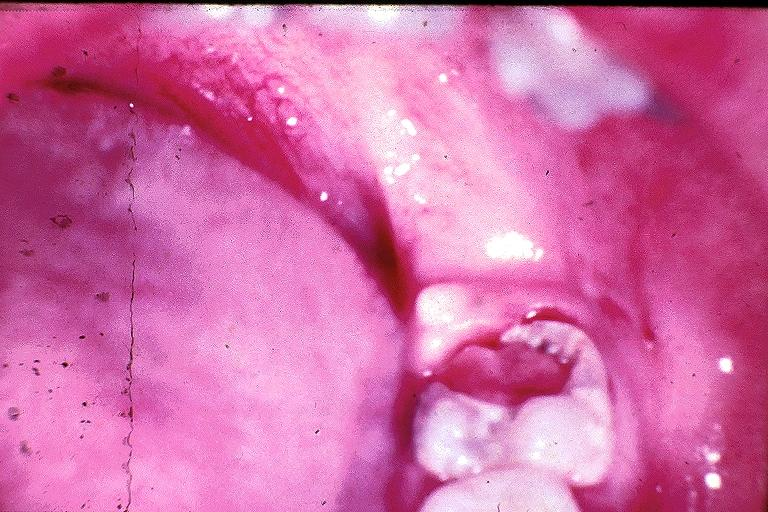what does this image show?
Answer the question using a single word or phrase. Chronic hyperplastic pulpitis 